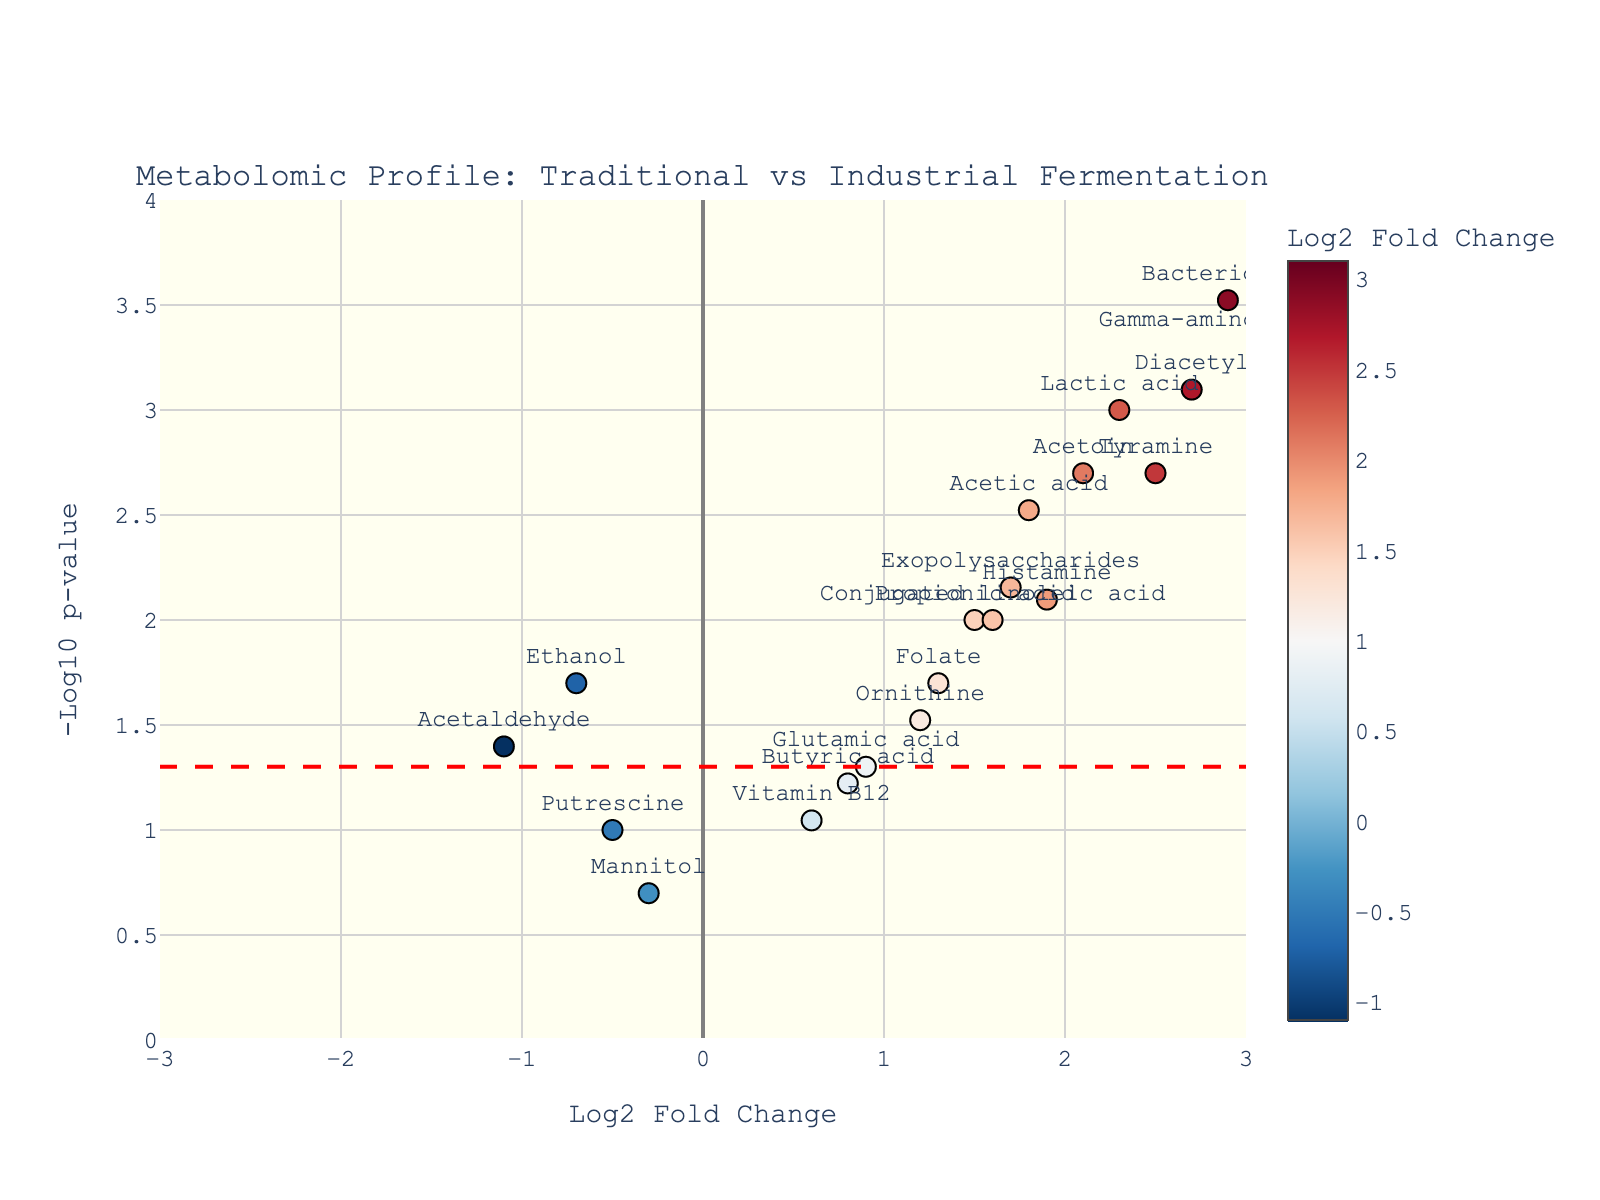What is the title of the plot? The title of the plot is displayed at the top of the figure. It helps in understanding what the plot represents. The title of the plot is "Metabolomic Profile: Traditional vs Industrial Fermentation."
Answer: Metabolomic Profile: Traditional vs Industrial Fermentation How many metabolites have a negative log2 fold change? To find how many metabolites have a negative log2 fold change, look for points on the left side (negative values) of the vertical axis. Visual inspection shows three such metabolites: Ethanol, Putrescine, and Acetaldehyde.
Answer: 3 Which metabolite has the highest log2 fold change? Look for the metabolite positioned farthest to the right on the x-axis; this would correspond to the highest log2 fold change. Gamma-aminobutyric acid (GABA) is farthest to the right with a log2 fold change of 3.1.
Answer: Gamma-aminobutyric acid Which metabolite has the lowest p-value? The lowest p-value corresponds to the highest y-axis value (-log10 p-value). Bacteriocins is at the highest point with a -log10 p-value, indicating the lowest p-value of 0.0003.
Answer: Bacteriocins Which metabolite shows a relatively moderate log2 fold change and just crosses the significance threshold? To find this, identify a metabolite near but above the horizontal red dashed line (significance threshold) with a moderate log2 fold change (near the center in x-axis values). Ornithine has a moderate log2 fold change (1.2) and just crosses the significance threshold line (-log10(0.05)).
Answer: Ornithine Between Diacetyl and Acetoin, which has a higher significance level? Compare the -log10 p-values (y-axis values) of Diacetyl and Acetoin. Diacetyl is higher up on the y-axis compared to Acetoin, indicating a more significant p-value.
Answer: Diacetyl What is the log2 fold change for Exopolysaccharides and does it show statistical significance? Exopolysaccharides have a log2 fold change around 1.7 (x-axis value) and its position is above the red dashed line, indicating a statistically significant p-value of 0.007.
Answer: 1.7, Yes Are there any metabolites that do not reach statistical significance (p-value > 0.05)? If yes, name them. Look for metabolites below the red dashed line, which indicates a p-value higher than 0.05. By inspecting, Glutamic acid, Putrescine, Butyric acid, and Mannitol fall below this line.
Answer: Glutamic acid, Putrescine, Butyric acid, Mannitol What is the average log2 fold change of metabolites with p-values less than 0.01? Identify metabolites with p-values less than 0.01, then calculate the average of their log2 fold changes. The relevant metabolites are: Lactic acid (2.3), Acetic acid (1.8), Gamma-aminobutyric acid (3.1), Tyramine (2.5), Diacetyl (2.7), Propionic acid (1.5), Acetoin (2.1), Exopolysaccharides (1.7), Bacteriocins (2.9), Conjugated linoleic acid (1.6). Their average log2 fold change is calculated as:
(2.3 + 1.8 + 3.1 + 2.5 + 2.7 + 1.5 + 2.1 + 1.7 + 2.9 + 1.6) / 10 = 2.12
Answer: 2.12 